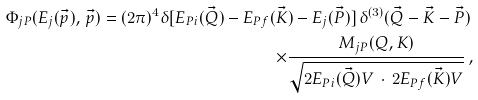Convert formula to latex. <formula><loc_0><loc_0><loc_500><loc_500>\Phi _ { j P } ( E _ { j } ( \vec { p } ) , \, \vec { p } ) = ( 2 \pi ) ^ { 4 } \delta [ E _ { P i } ( \vec { Q } ) - E _ { P f } ( \vec { K } ) - E _ { j } ( \vec { P } ) ] \, \delta ^ { ( 3 ) } ( \vec { Q } - \vec { K } - \vec { P } ) \, \\ \times \frac { M _ { j P } ( Q , K ) } { \sqrt { 2 E _ { P i } ( \vec { Q } ) V \, \cdot \, 2 E _ { P f } ( \vec { K } ) V } } \, ,</formula> 